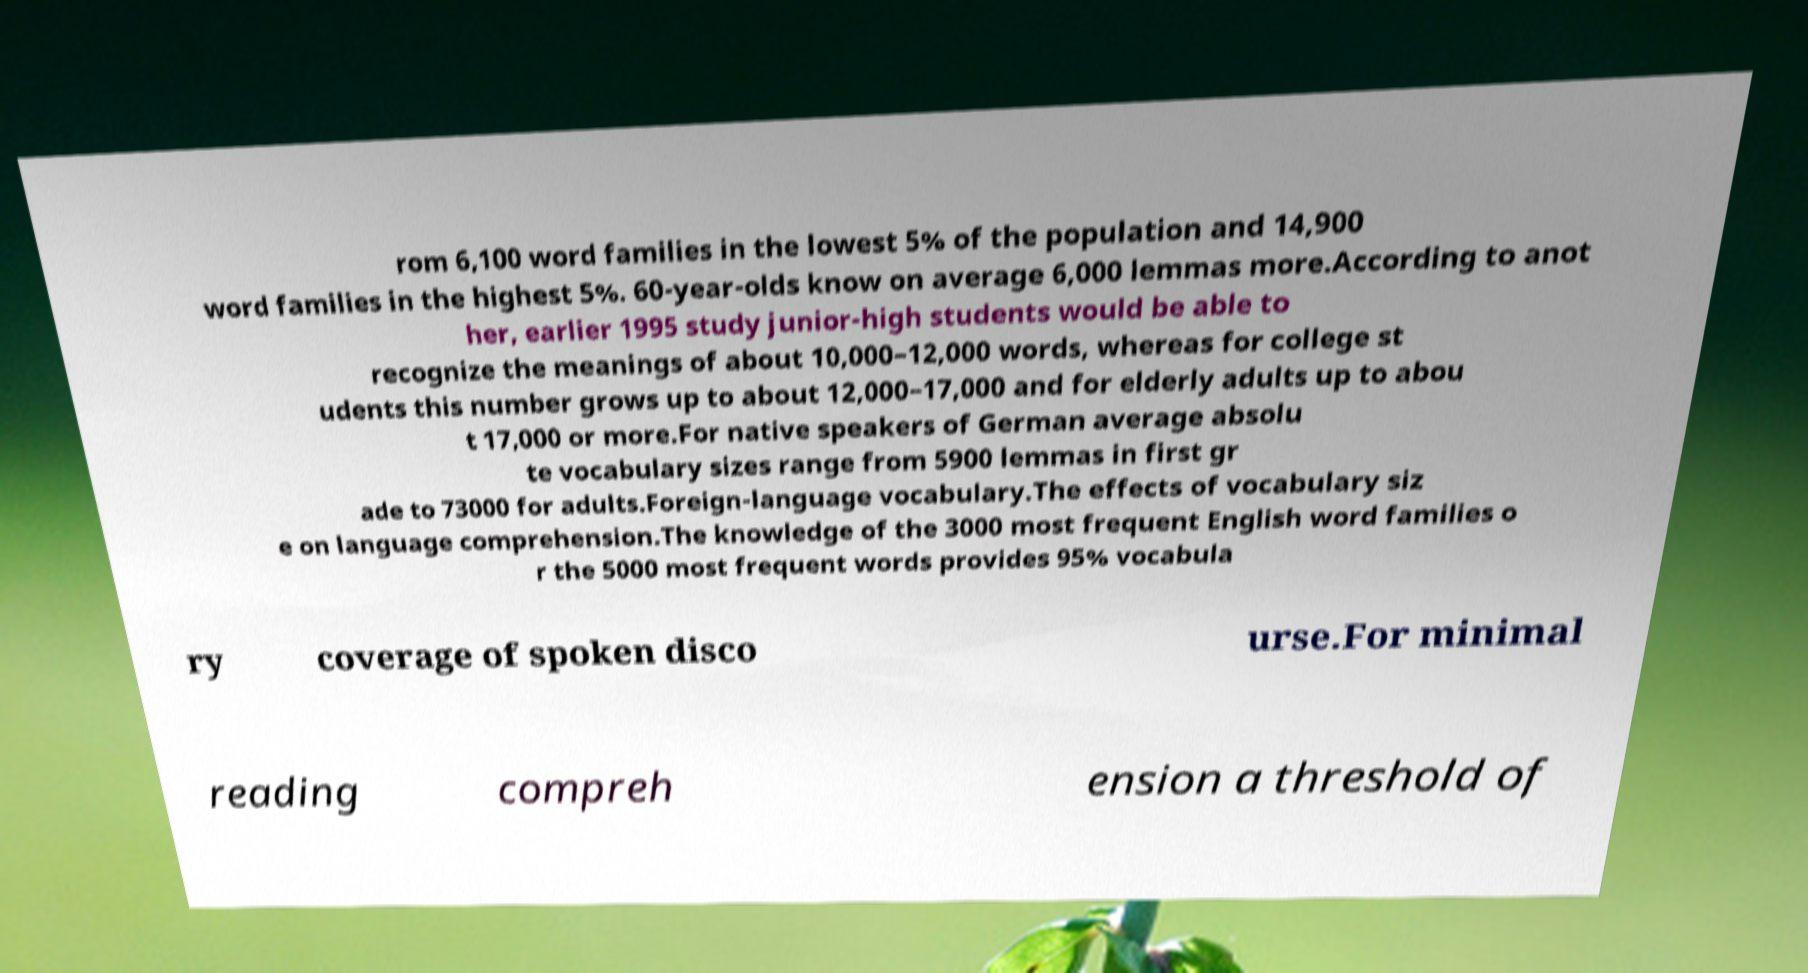I need the written content from this picture converted into text. Can you do that? rom 6,100 word families in the lowest 5% of the population and 14,900 word families in the highest 5%. 60-year-olds know on average 6,000 lemmas more.According to anot her, earlier 1995 study junior-high students would be able to recognize the meanings of about 10,000–12,000 words, whereas for college st udents this number grows up to about 12,000–17,000 and for elderly adults up to abou t 17,000 or more.For native speakers of German average absolu te vocabulary sizes range from 5900 lemmas in first gr ade to 73000 for adults.Foreign-language vocabulary.The effects of vocabulary siz e on language comprehension.The knowledge of the 3000 most frequent English word families o r the 5000 most frequent words provides 95% vocabula ry coverage of spoken disco urse.For minimal reading compreh ension a threshold of 